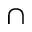<formula> <loc_0><loc_0><loc_500><loc_500>\cap</formula> 